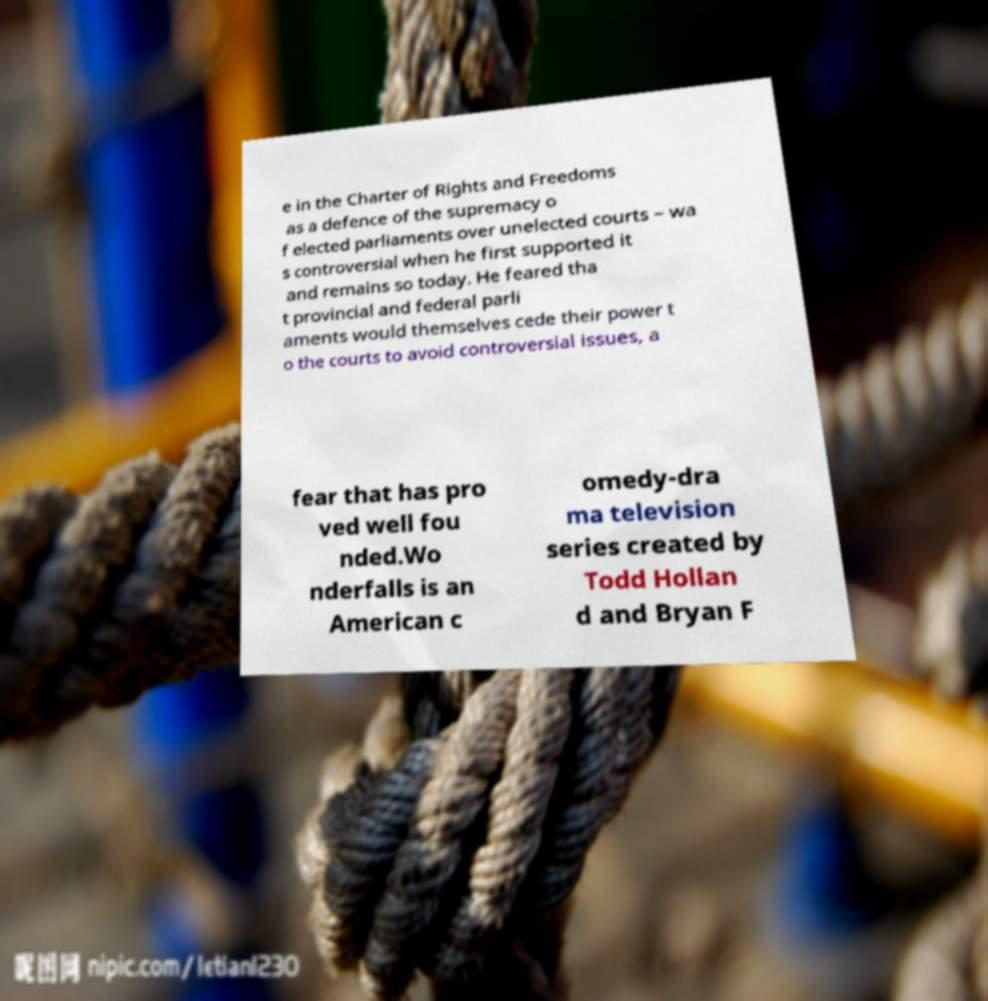There's text embedded in this image that I need extracted. Can you transcribe it verbatim? e in the Charter of Rights and Freedoms as a defence of the supremacy o f elected parliaments over unelected courts – wa s controversial when he first supported it and remains so today. He feared tha t provincial and federal parli aments would themselves cede their power t o the courts to avoid controversial issues, a fear that has pro ved well fou nded.Wo nderfalls is an American c omedy-dra ma television series created by Todd Hollan d and Bryan F 